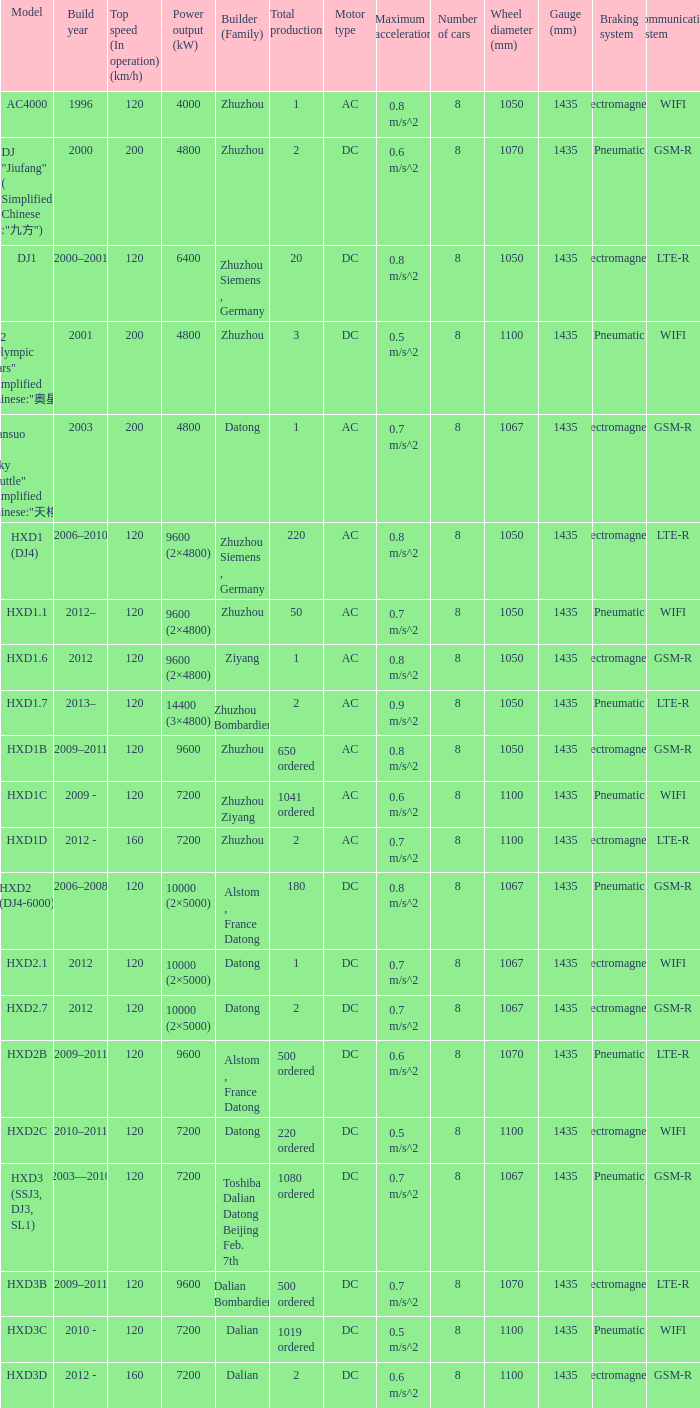What model has a builder of zhuzhou, and a power output of 9600 (kw)? HXD1B. 